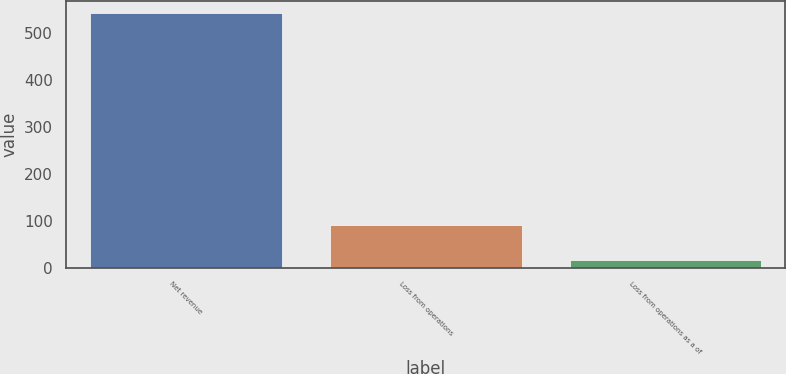Convert chart. <chart><loc_0><loc_0><loc_500><loc_500><bar_chart><fcel>Net revenue<fcel>Loss from operations<fcel>Loss from operations as a of<nl><fcel>543<fcel>91<fcel>16.8<nl></chart> 